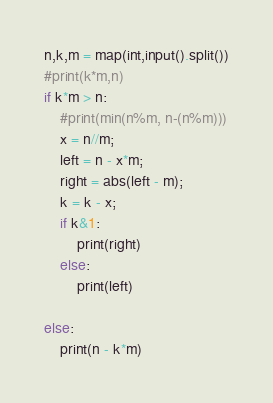Convert code to text. <code><loc_0><loc_0><loc_500><loc_500><_Python_>n,k,m = map(int,input().split())
#print(k*m,n)
if k*m > n:
    #print(min(n%m, n-(n%m)))
    x = n//m;
    left = n - x*m;
    right = abs(left - m);
    k = k - x;
    if k&1:
        print(right)
    else:
        print(left)
    
else:
    print(n - k*m)

</code> 